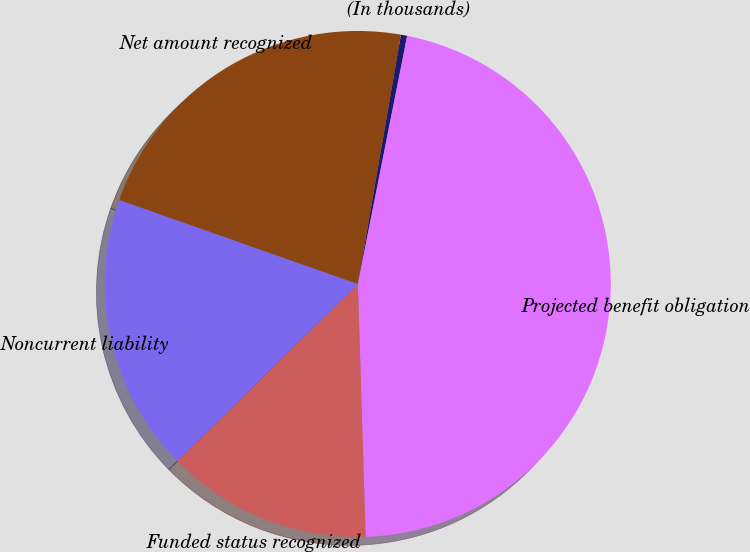Convert chart to OTSL. <chart><loc_0><loc_0><loc_500><loc_500><pie_chart><fcel>(In thousands)<fcel>Projected benefit obligation<fcel>Funded status recognized<fcel>Noncurrent liability<fcel>Net amount recognized<nl><fcel>0.4%<fcel>46.38%<fcel>13.14%<fcel>17.74%<fcel>22.34%<nl></chart> 